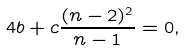<formula> <loc_0><loc_0><loc_500><loc_500>4 b + c \frac { ( n - 2 ) ^ { 2 } } { n - 1 } = 0 ,</formula> 